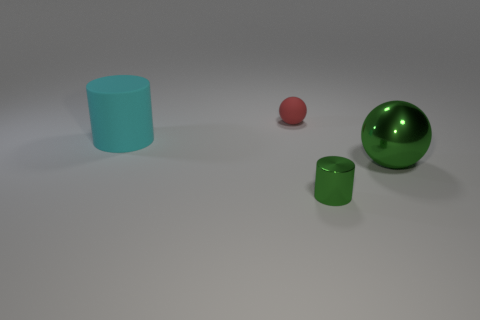Is the size of the cyan rubber cylinder the same as the metal thing to the left of the big green object?
Your response must be concise. No. What is the color of the shiny thing that is on the left side of the green shiny thing behind the small metal cylinder?
Offer a terse response. Green. How many objects are metallic things to the right of the green cylinder or tiny metallic objects in front of the large green metallic thing?
Your answer should be very brief. 2. Is the red thing the same size as the green metallic cylinder?
Make the answer very short. Yes. Does the small thing on the right side of the tiny red ball have the same shape as the big thing that is on the left side of the large metallic sphere?
Your answer should be compact. Yes. How big is the red rubber ball?
Offer a very short reply. Small. What is the material of the ball behind the large object behind the big object to the right of the matte ball?
Offer a terse response. Rubber. How many other things are the same color as the rubber ball?
Your answer should be compact. 0. How many green objects are either large metallic things or small metallic objects?
Provide a succinct answer. 2. What is the material of the large object to the left of the small green cylinder?
Ensure brevity in your answer.  Rubber. 